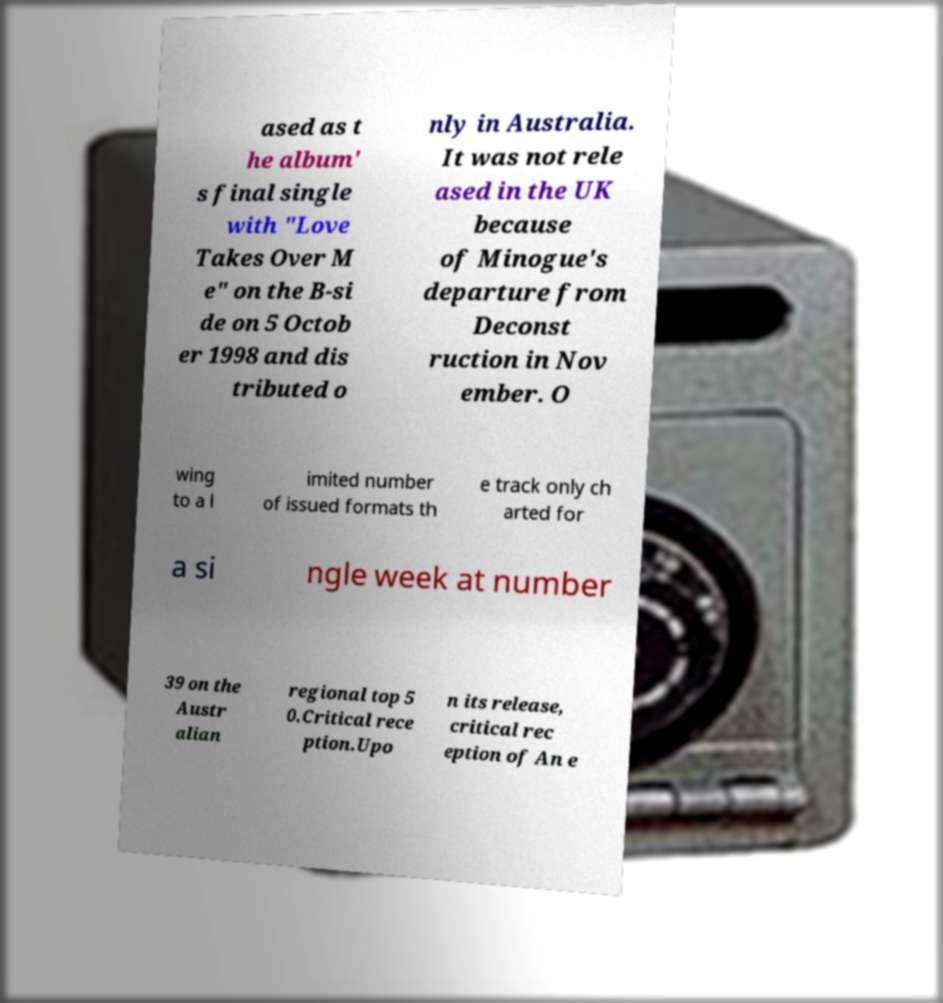Can you accurately transcribe the text from the provided image for me? ased as t he album' s final single with "Love Takes Over M e" on the B-si de on 5 Octob er 1998 and dis tributed o nly in Australia. It was not rele ased in the UK because of Minogue's departure from Deconst ruction in Nov ember. O wing to a l imited number of issued formats th e track only ch arted for a si ngle week at number 39 on the Austr alian regional top 5 0.Critical rece ption.Upo n its release, critical rec eption of An e 